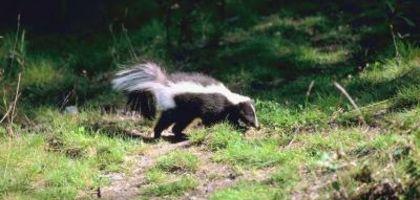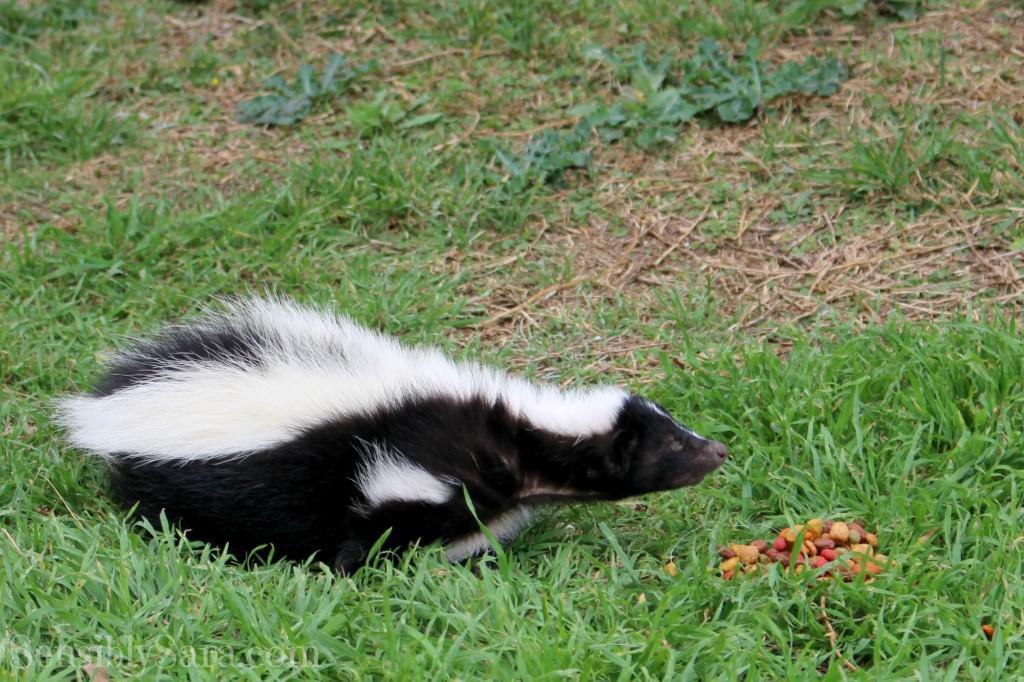The first image is the image on the left, the second image is the image on the right. Analyze the images presented: Is the assertion "The skunk in the right image is facing right." valid? Answer yes or no. Yes. The first image is the image on the left, the second image is the image on the right. Analyze the images presented: Is the assertion "One skunk is on all fours facing directly forward, and the other skunk is standing on all fours with its body turned rightward and gaze angled forward." valid? Answer yes or no. No. 